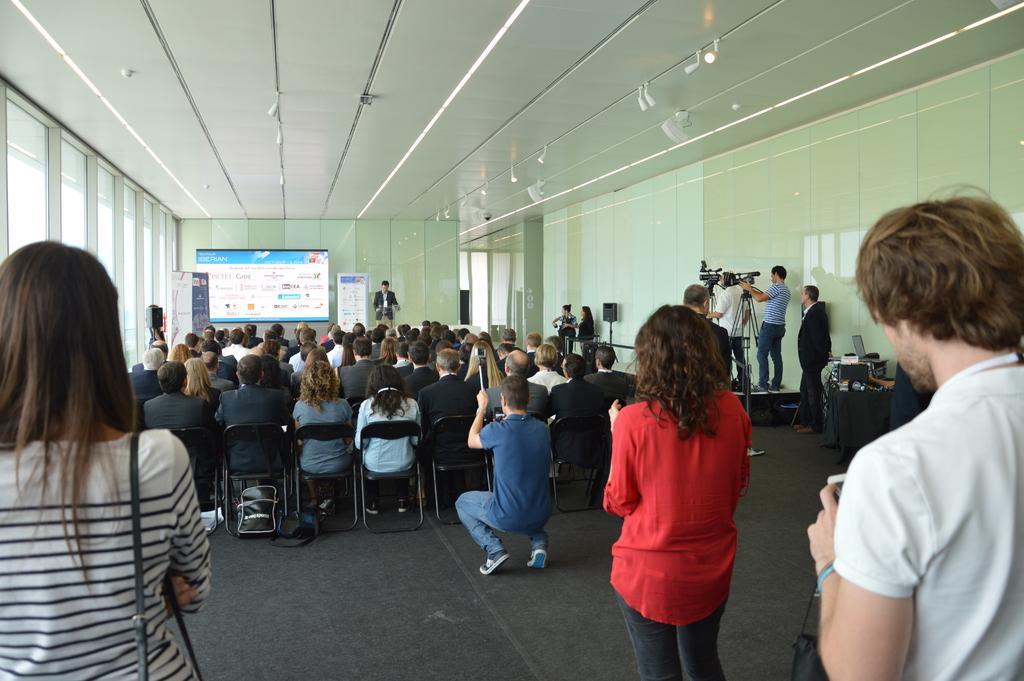Could you give a brief overview of what you see in this image? In this picture we can see a group of people,some people are sitting on chairs,some people are standing and in the background we can see a screen,wall,roof. 